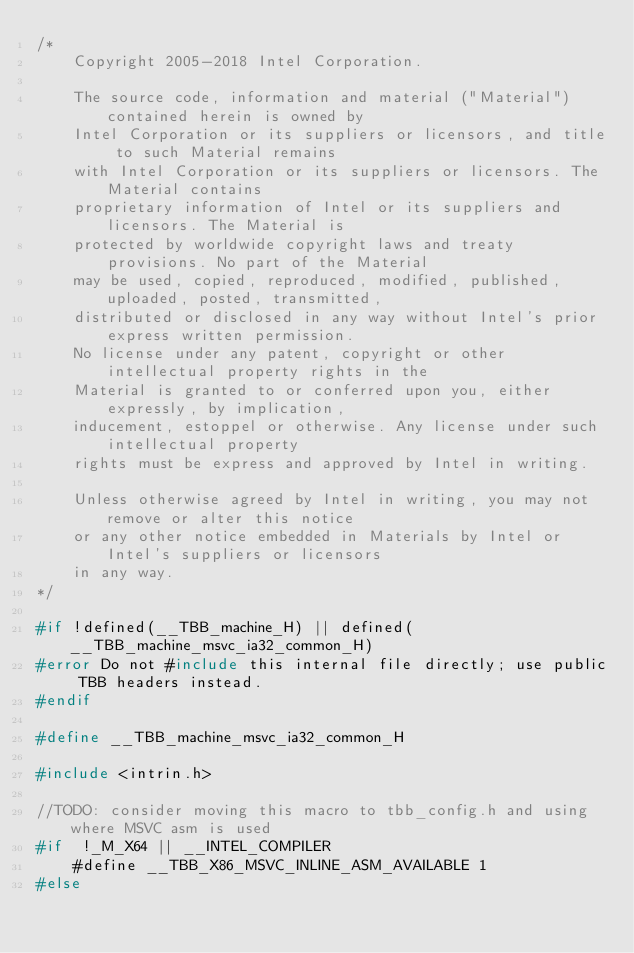Convert code to text. <code><loc_0><loc_0><loc_500><loc_500><_C_>/*
    Copyright 2005-2018 Intel Corporation.

    The source code, information and material ("Material") contained herein is owned by
    Intel Corporation or its suppliers or licensors, and title to such Material remains
    with Intel Corporation or its suppliers or licensors. The Material contains
    proprietary information of Intel or its suppliers and licensors. The Material is
    protected by worldwide copyright laws and treaty provisions. No part of the Material
    may be used, copied, reproduced, modified, published, uploaded, posted, transmitted,
    distributed or disclosed in any way without Intel's prior express written permission.
    No license under any patent, copyright or other intellectual property rights in the
    Material is granted to or conferred upon you, either expressly, by implication,
    inducement, estoppel or otherwise. Any license under such intellectual property
    rights must be express and approved by Intel in writing.

    Unless otherwise agreed by Intel in writing, you may not remove or alter this notice
    or any other notice embedded in Materials by Intel or Intel's suppliers or licensors
    in any way.
*/

#if !defined(__TBB_machine_H) || defined(__TBB_machine_msvc_ia32_common_H)
#error Do not #include this internal file directly; use public TBB headers instead.
#endif

#define __TBB_machine_msvc_ia32_common_H

#include <intrin.h>

//TODO: consider moving this macro to tbb_config.h and using where MSVC asm is used
#if  !_M_X64 || __INTEL_COMPILER
    #define __TBB_X86_MSVC_INLINE_ASM_AVAILABLE 1
#else</code> 